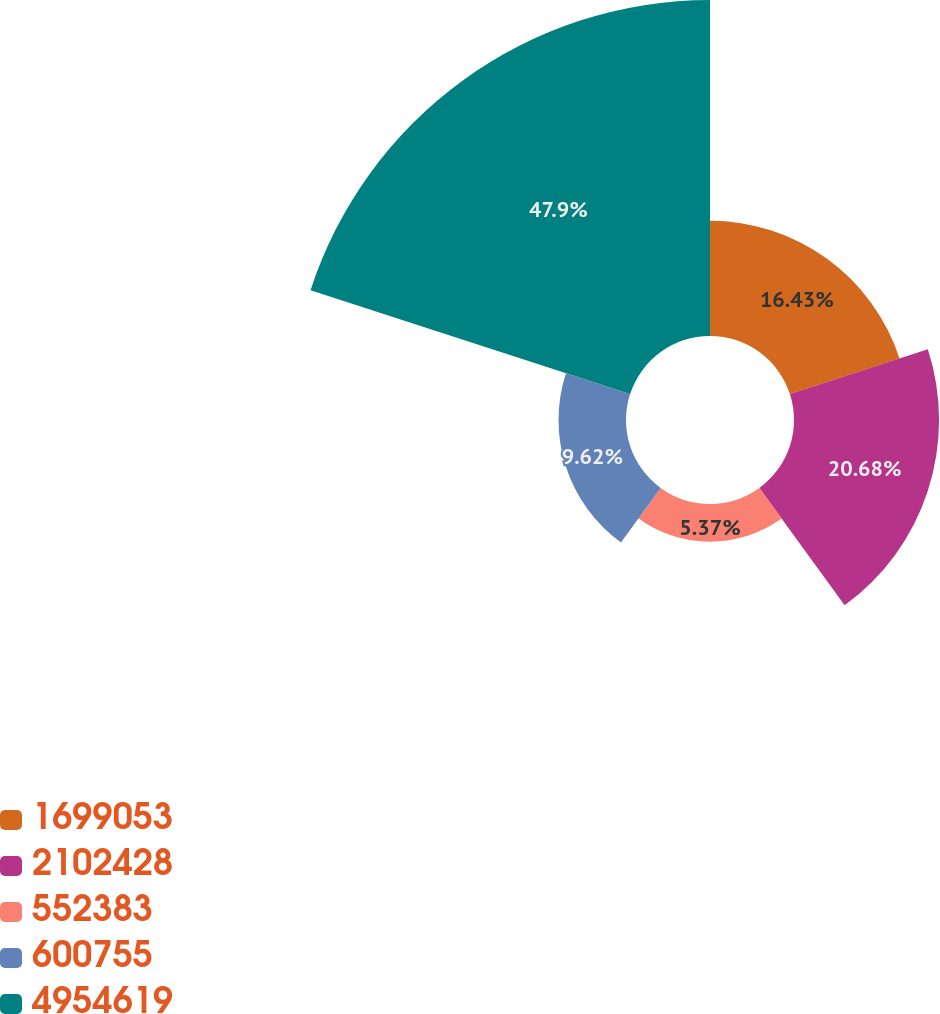<chart> <loc_0><loc_0><loc_500><loc_500><pie_chart><fcel>1699053<fcel>2102428<fcel>552383<fcel>600755<fcel>4954619<nl><fcel>16.43%<fcel>20.68%<fcel>5.37%<fcel>9.62%<fcel>47.9%<nl></chart> 